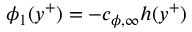Convert formula to latex. <formula><loc_0><loc_0><loc_500><loc_500>\phi _ { 1 } ( y ^ { + } ) = - c _ { \phi , \infty } h ( y ^ { + } )</formula> 